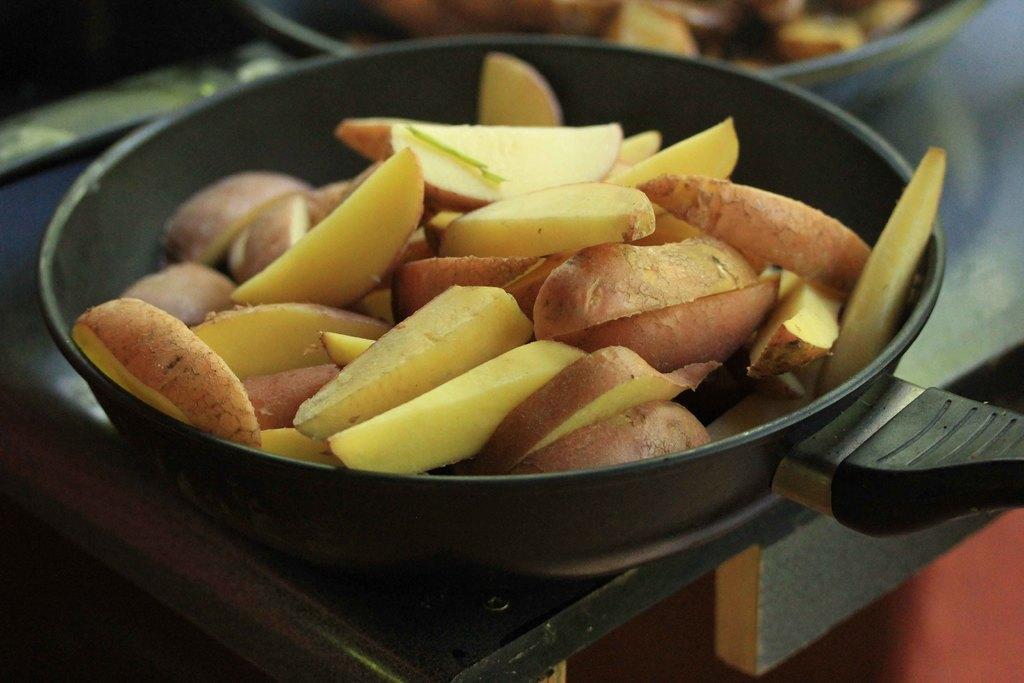Describe this image in one or two sentences. In this image we can see some fruits in the pan and the pan is placed on the table. 